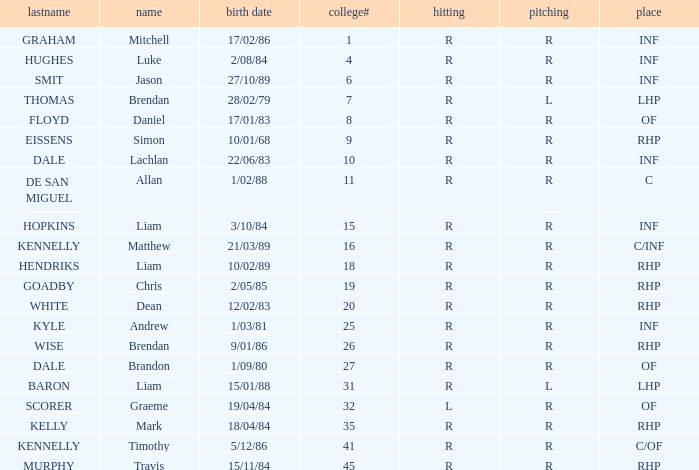Which batter has a uni# of 31? R. 